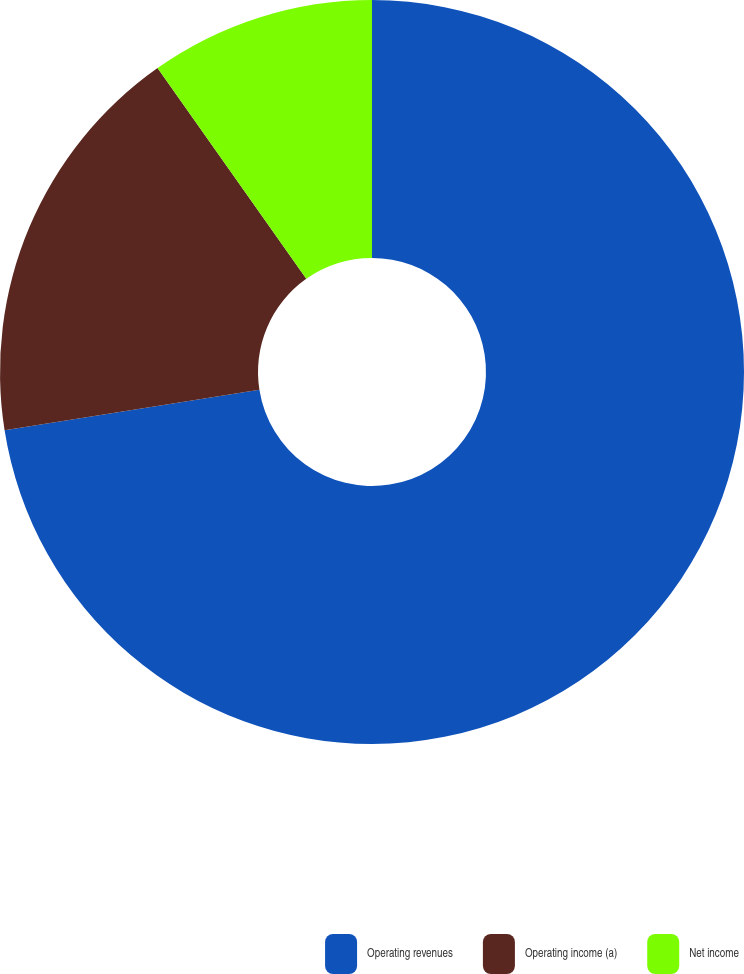Convert chart to OTSL. <chart><loc_0><loc_0><loc_500><loc_500><pie_chart><fcel>Operating revenues<fcel>Operating income (a)<fcel>Net income<nl><fcel>72.5%<fcel>17.72%<fcel>9.78%<nl></chart> 